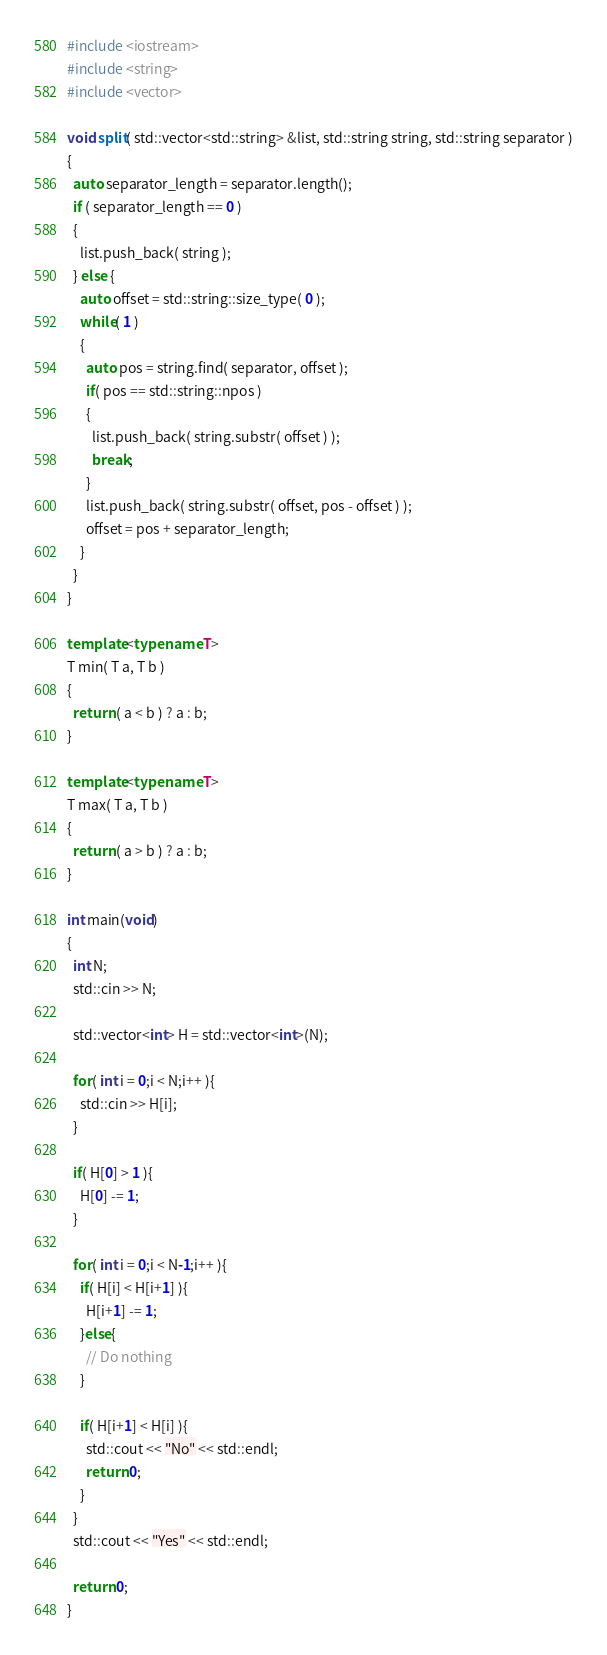Convert code to text. <code><loc_0><loc_0><loc_500><loc_500><_C++_>#include <iostream>
#include <string>
#include <vector>

void split( std::vector<std::string> &list, std::string string, std::string separator )
{
  auto separator_length = separator.length();
  if ( separator_length == 0 )
  {
    list.push_back( string );
  } else {
    auto offset = std::string::size_type( 0 );
    while( 1 )
    {
      auto pos = string.find( separator, offset );
      if( pos == std::string::npos )
      {
        list.push_back( string.substr( offset ) );
        break;
      }
      list.push_back( string.substr( offset, pos - offset ) );
      offset = pos + separator_length;
    }
  }
}

template<typename T>
T min( T a, T b )
{
  return ( a < b ) ? a : b;
}

template<typename T>
T max( T a, T b )
{
  return ( a > b ) ? a : b;
}

int main(void)
{
  int N;
  std::cin >> N;
  
  std::vector<int> H = std::vector<int>(N);

  for( int i = 0;i < N;i++ ){
    std::cin >> H[i];
  }

  if( H[0] > 1 ){
    H[0] -= 1;
  }

  for( int i = 0;i < N-1;i++ ){
    if( H[i] < H[i+1] ){
      H[i+1] -= 1;
    }else{
      // Do nothing
    }

    if( H[i+1] < H[i] ){
      std::cout << "No" << std::endl;
      return 0;
    }
  }
  std::cout << "Yes" << std::endl;

  return 0;
}
</code> 